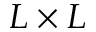Convert formula to latex. <formula><loc_0><loc_0><loc_500><loc_500>L \times L</formula> 